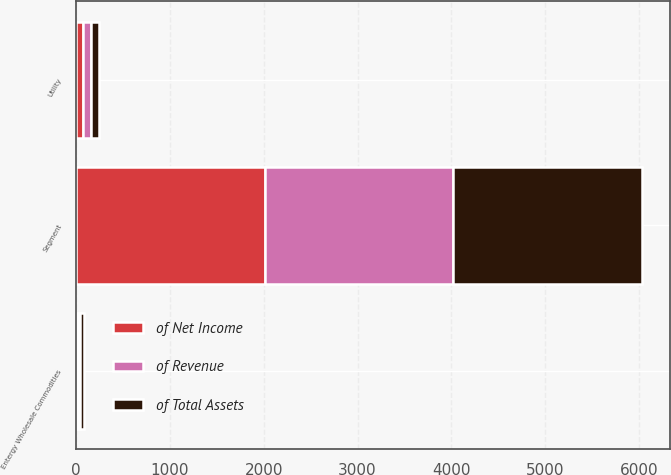Convert chart. <chart><loc_0><loc_0><loc_500><loc_500><stacked_bar_chart><ecel><fcel>Segment<fcel>Utility<fcel>Entergy Wholesale Commodities<nl><fcel>of Net Income<fcel>2011<fcel>79<fcel>21<nl><fcel>of Total Assets<fcel>2011<fcel>82<fcel>36<nl><fcel>of Revenue<fcel>2011<fcel>80<fcel>26<nl></chart> 